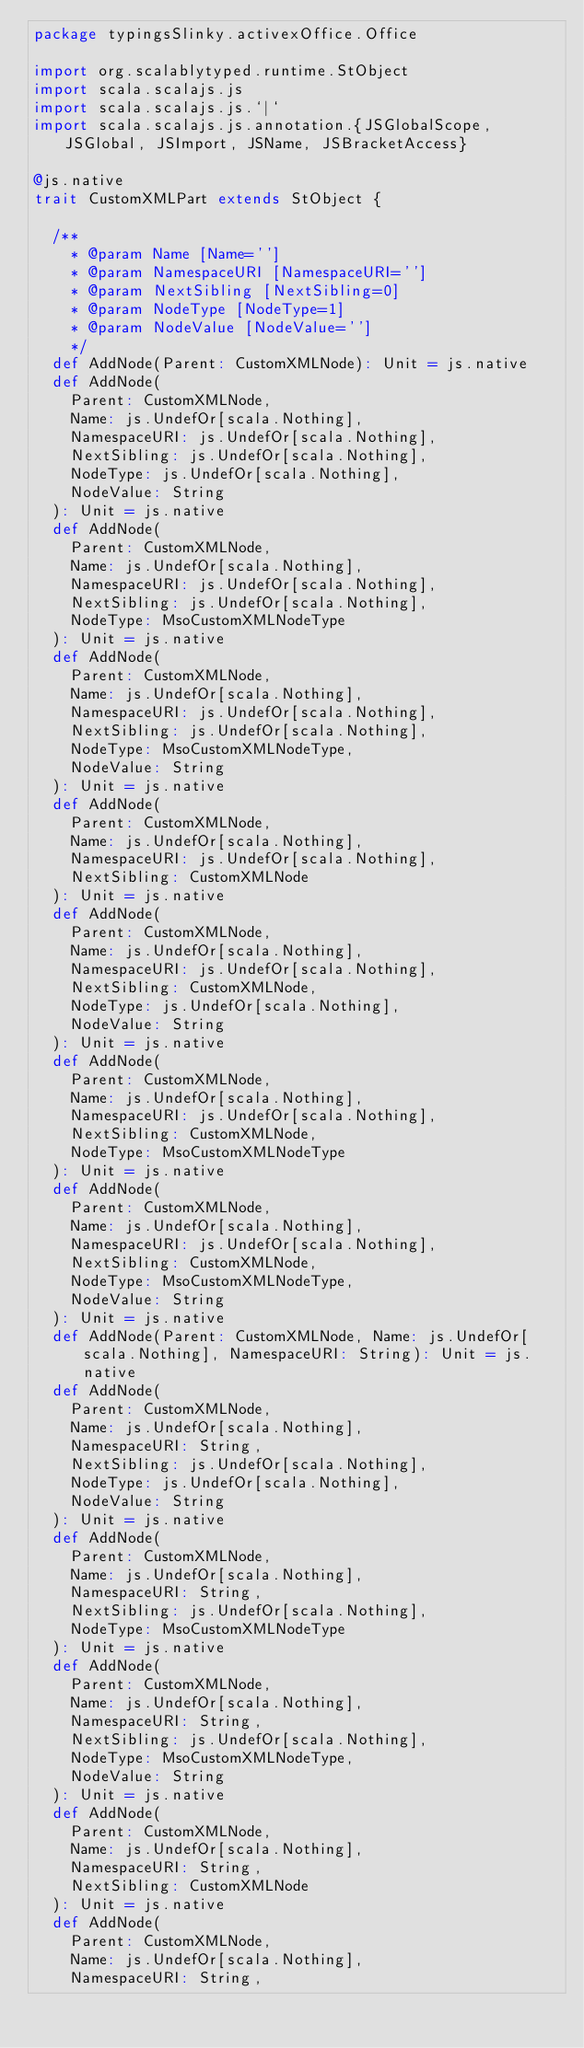<code> <loc_0><loc_0><loc_500><loc_500><_Scala_>package typingsSlinky.activexOffice.Office

import org.scalablytyped.runtime.StObject
import scala.scalajs.js
import scala.scalajs.js.`|`
import scala.scalajs.js.annotation.{JSGlobalScope, JSGlobal, JSImport, JSName, JSBracketAccess}

@js.native
trait CustomXMLPart extends StObject {
  
  /**
    * @param Name [Name='']
    * @param NamespaceURI [NamespaceURI='']
    * @param NextSibling [NextSibling=0]
    * @param NodeType [NodeType=1]
    * @param NodeValue [NodeValue='']
    */
  def AddNode(Parent: CustomXMLNode): Unit = js.native
  def AddNode(
    Parent: CustomXMLNode,
    Name: js.UndefOr[scala.Nothing],
    NamespaceURI: js.UndefOr[scala.Nothing],
    NextSibling: js.UndefOr[scala.Nothing],
    NodeType: js.UndefOr[scala.Nothing],
    NodeValue: String
  ): Unit = js.native
  def AddNode(
    Parent: CustomXMLNode,
    Name: js.UndefOr[scala.Nothing],
    NamespaceURI: js.UndefOr[scala.Nothing],
    NextSibling: js.UndefOr[scala.Nothing],
    NodeType: MsoCustomXMLNodeType
  ): Unit = js.native
  def AddNode(
    Parent: CustomXMLNode,
    Name: js.UndefOr[scala.Nothing],
    NamespaceURI: js.UndefOr[scala.Nothing],
    NextSibling: js.UndefOr[scala.Nothing],
    NodeType: MsoCustomXMLNodeType,
    NodeValue: String
  ): Unit = js.native
  def AddNode(
    Parent: CustomXMLNode,
    Name: js.UndefOr[scala.Nothing],
    NamespaceURI: js.UndefOr[scala.Nothing],
    NextSibling: CustomXMLNode
  ): Unit = js.native
  def AddNode(
    Parent: CustomXMLNode,
    Name: js.UndefOr[scala.Nothing],
    NamespaceURI: js.UndefOr[scala.Nothing],
    NextSibling: CustomXMLNode,
    NodeType: js.UndefOr[scala.Nothing],
    NodeValue: String
  ): Unit = js.native
  def AddNode(
    Parent: CustomXMLNode,
    Name: js.UndefOr[scala.Nothing],
    NamespaceURI: js.UndefOr[scala.Nothing],
    NextSibling: CustomXMLNode,
    NodeType: MsoCustomXMLNodeType
  ): Unit = js.native
  def AddNode(
    Parent: CustomXMLNode,
    Name: js.UndefOr[scala.Nothing],
    NamespaceURI: js.UndefOr[scala.Nothing],
    NextSibling: CustomXMLNode,
    NodeType: MsoCustomXMLNodeType,
    NodeValue: String
  ): Unit = js.native
  def AddNode(Parent: CustomXMLNode, Name: js.UndefOr[scala.Nothing], NamespaceURI: String): Unit = js.native
  def AddNode(
    Parent: CustomXMLNode,
    Name: js.UndefOr[scala.Nothing],
    NamespaceURI: String,
    NextSibling: js.UndefOr[scala.Nothing],
    NodeType: js.UndefOr[scala.Nothing],
    NodeValue: String
  ): Unit = js.native
  def AddNode(
    Parent: CustomXMLNode,
    Name: js.UndefOr[scala.Nothing],
    NamespaceURI: String,
    NextSibling: js.UndefOr[scala.Nothing],
    NodeType: MsoCustomXMLNodeType
  ): Unit = js.native
  def AddNode(
    Parent: CustomXMLNode,
    Name: js.UndefOr[scala.Nothing],
    NamespaceURI: String,
    NextSibling: js.UndefOr[scala.Nothing],
    NodeType: MsoCustomXMLNodeType,
    NodeValue: String
  ): Unit = js.native
  def AddNode(
    Parent: CustomXMLNode,
    Name: js.UndefOr[scala.Nothing],
    NamespaceURI: String,
    NextSibling: CustomXMLNode
  ): Unit = js.native
  def AddNode(
    Parent: CustomXMLNode,
    Name: js.UndefOr[scala.Nothing],
    NamespaceURI: String,</code> 